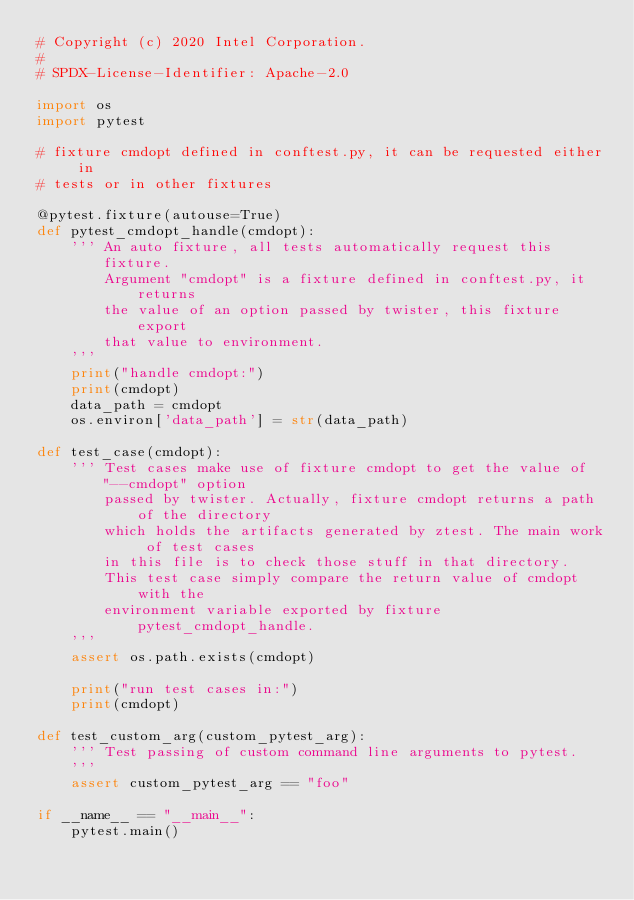<code> <loc_0><loc_0><loc_500><loc_500><_Python_># Copyright (c) 2020 Intel Corporation.
#
# SPDX-License-Identifier: Apache-2.0

import os
import pytest

# fixture cmdopt defined in conftest.py, it can be requested either in
# tests or in other fixtures

@pytest.fixture(autouse=True)
def pytest_cmdopt_handle(cmdopt):
    ''' An auto fixture, all tests automatically request this fixture.
        Argument "cmdopt" is a fixture defined in conftest.py, it returns
        the value of an option passed by twister, this fixture export
        that value to environment.
    '''
    print("handle cmdopt:")
    print(cmdopt)
    data_path = cmdopt
    os.environ['data_path'] = str(data_path)

def test_case(cmdopt):
    ''' Test cases make use of fixture cmdopt to get the value of "--cmdopt" option
        passed by twister. Actually, fixture cmdopt returns a path of the directory
        which holds the artifacts generated by ztest. The main work of test cases
        in this file is to check those stuff in that directory.
        This test case simply compare the return value of cmdopt with the
        environment variable exported by fixture pytest_cmdopt_handle.
    '''
    assert os.path.exists(cmdopt)

    print("run test cases in:")
    print(cmdopt)

def test_custom_arg(custom_pytest_arg):
    ''' Test passing of custom command line arguments to pytest.
    '''
    assert custom_pytest_arg == "foo"

if __name__ == "__main__":
    pytest.main()
</code> 